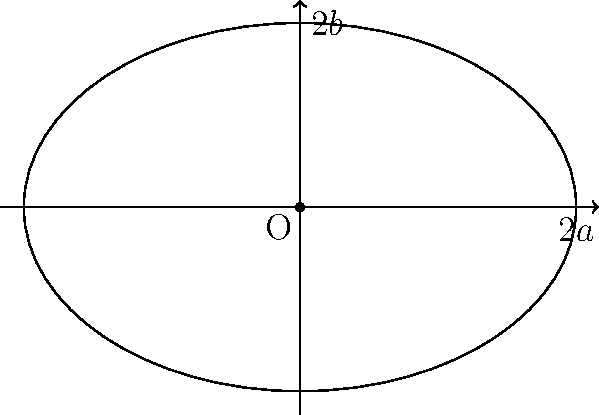As a sports reporter covering a new stadium construction, you need to calculate the surface area of the elliptical roof. The stadium architect informs you that the roof's shape is an ellipse with a major axis of 120 meters and a minor axis of 80 meters. What is the approximate surface area of the stadium roof in square meters? To calculate the approximate surface area of an elliptical stadium roof, we can use Ramanujan's approximation for the surface area of an ellipse. Let's break it down step-by-step:

1) The formula for Ramanujan's approximation is:

   $$A \approx \pi ab \left[1 + \frac{3h}{10 + \sqrt{4-3h}}\right]$$

   Where $a$ is half the major axis, $b$ is half the minor axis, and $h = \frac{(a-b)^2}{(a+b)^2}$

2) Given:
   - Major axis = 120 m, so $a = 60$ m
   - Minor axis = 80 m, so $b = 40$ m

3) Calculate $h$:
   $$h = \frac{(60-40)^2}{(60+40)^2} = \frac{400}{10000} = 0.04$$

4) Substitute the values into Ramanujan's formula:

   $$A \approx \pi(60)(40) \left[1 + \frac{3(0.04)}{10 + \sqrt{4-3(0.04)}}\right]$$

5) Simplify:
   $$A \approx 7539.82 \left[1 + \frac{0.12}{10 + \sqrt{3.88}}\right]$$
   $$A \approx 7539.82 [1 + 0.0116]$$
   $$A \approx 7539.82 (1.0116)$$
   $$A \approx 7627.28$$

6) Round to the nearest square meter:
   $$A \approx 7627 \text{ m}^2$$

Therefore, the approximate surface area of the stadium roof is 7627 square meters.
Answer: 7627 m² 